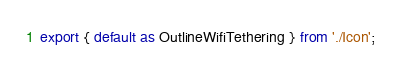<code> <loc_0><loc_0><loc_500><loc_500><_TypeScript_>export { default as OutlineWifiTethering } from './Icon';
</code> 